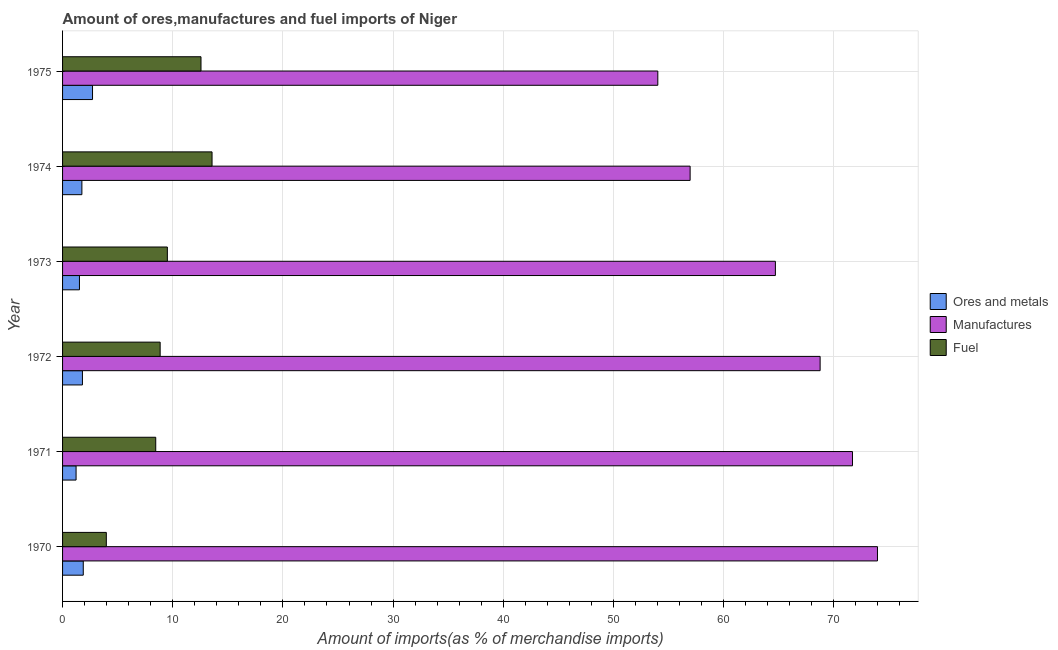How many different coloured bars are there?
Provide a short and direct response. 3. Are the number of bars per tick equal to the number of legend labels?
Give a very brief answer. Yes. Are the number of bars on each tick of the Y-axis equal?
Provide a short and direct response. Yes. What is the percentage of manufactures imports in 1973?
Offer a terse response. 64.71. Across all years, what is the maximum percentage of fuel imports?
Provide a succinct answer. 13.57. Across all years, what is the minimum percentage of manufactures imports?
Make the answer very short. 54.03. In which year was the percentage of ores and metals imports maximum?
Offer a terse response. 1975. What is the total percentage of manufactures imports in the graph?
Keep it short and to the point. 390.14. What is the difference between the percentage of manufactures imports in 1971 and that in 1972?
Offer a very short reply. 2.94. What is the difference between the percentage of ores and metals imports in 1973 and the percentage of manufactures imports in 1975?
Make the answer very short. -52.5. What is the average percentage of ores and metals imports per year?
Provide a succinct answer. 1.82. In the year 1971, what is the difference between the percentage of fuel imports and percentage of manufactures imports?
Your response must be concise. -63.25. What is the ratio of the percentage of fuel imports in 1971 to that in 1972?
Provide a short and direct response. 0.95. What is the difference between the highest and the second highest percentage of fuel imports?
Your answer should be very brief. 1. What is the difference between the highest and the lowest percentage of ores and metals imports?
Your answer should be compact. 1.49. Is the sum of the percentage of ores and metals imports in 1970 and 1975 greater than the maximum percentage of fuel imports across all years?
Your answer should be compact. No. What does the 1st bar from the top in 1970 represents?
Offer a terse response. Fuel. What does the 2nd bar from the bottom in 1971 represents?
Keep it short and to the point. Manufactures. Is it the case that in every year, the sum of the percentage of ores and metals imports and percentage of manufactures imports is greater than the percentage of fuel imports?
Provide a short and direct response. Yes. Are the values on the major ticks of X-axis written in scientific E-notation?
Provide a succinct answer. No. Does the graph contain any zero values?
Offer a terse response. No. Where does the legend appear in the graph?
Keep it short and to the point. Center right. How are the legend labels stacked?
Your answer should be very brief. Vertical. What is the title of the graph?
Offer a very short reply. Amount of ores,manufactures and fuel imports of Niger. Does "ICT services" appear as one of the legend labels in the graph?
Ensure brevity in your answer.  No. What is the label or title of the X-axis?
Give a very brief answer. Amount of imports(as % of merchandise imports). What is the label or title of the Y-axis?
Provide a short and direct response. Year. What is the Amount of imports(as % of merchandise imports) in Ores and metals in 1970?
Provide a short and direct response. 1.88. What is the Amount of imports(as % of merchandise imports) in Manufactures in 1970?
Provide a short and direct response. 73.97. What is the Amount of imports(as % of merchandise imports) of Fuel in 1970?
Ensure brevity in your answer.  3.97. What is the Amount of imports(as % of merchandise imports) of Ores and metals in 1971?
Ensure brevity in your answer.  1.23. What is the Amount of imports(as % of merchandise imports) in Manufactures in 1971?
Your answer should be very brief. 71.7. What is the Amount of imports(as % of merchandise imports) in Fuel in 1971?
Your answer should be very brief. 8.46. What is the Amount of imports(as % of merchandise imports) of Ores and metals in 1972?
Keep it short and to the point. 1.8. What is the Amount of imports(as % of merchandise imports) of Manufactures in 1972?
Make the answer very short. 68.77. What is the Amount of imports(as % of merchandise imports) in Fuel in 1972?
Your answer should be very brief. 8.86. What is the Amount of imports(as % of merchandise imports) of Ores and metals in 1973?
Your answer should be very brief. 1.53. What is the Amount of imports(as % of merchandise imports) of Manufactures in 1973?
Offer a terse response. 64.71. What is the Amount of imports(as % of merchandise imports) of Fuel in 1973?
Offer a terse response. 9.51. What is the Amount of imports(as % of merchandise imports) of Ores and metals in 1974?
Offer a very short reply. 1.75. What is the Amount of imports(as % of merchandise imports) in Manufactures in 1974?
Keep it short and to the point. 56.97. What is the Amount of imports(as % of merchandise imports) of Fuel in 1974?
Provide a short and direct response. 13.57. What is the Amount of imports(as % of merchandise imports) of Ores and metals in 1975?
Your response must be concise. 2.72. What is the Amount of imports(as % of merchandise imports) of Manufactures in 1975?
Your response must be concise. 54.03. What is the Amount of imports(as % of merchandise imports) of Fuel in 1975?
Keep it short and to the point. 12.57. Across all years, what is the maximum Amount of imports(as % of merchandise imports) in Ores and metals?
Your response must be concise. 2.72. Across all years, what is the maximum Amount of imports(as % of merchandise imports) of Manufactures?
Your response must be concise. 73.97. Across all years, what is the maximum Amount of imports(as % of merchandise imports) in Fuel?
Provide a succinct answer. 13.57. Across all years, what is the minimum Amount of imports(as % of merchandise imports) of Ores and metals?
Your answer should be very brief. 1.23. Across all years, what is the minimum Amount of imports(as % of merchandise imports) in Manufactures?
Offer a terse response. 54.03. Across all years, what is the minimum Amount of imports(as % of merchandise imports) of Fuel?
Ensure brevity in your answer.  3.97. What is the total Amount of imports(as % of merchandise imports) in Ores and metals in the graph?
Provide a succinct answer. 10.92. What is the total Amount of imports(as % of merchandise imports) in Manufactures in the graph?
Offer a very short reply. 390.14. What is the total Amount of imports(as % of merchandise imports) of Fuel in the graph?
Keep it short and to the point. 56.93. What is the difference between the Amount of imports(as % of merchandise imports) of Ores and metals in 1970 and that in 1971?
Give a very brief answer. 0.65. What is the difference between the Amount of imports(as % of merchandise imports) of Manufactures in 1970 and that in 1971?
Offer a terse response. 2.27. What is the difference between the Amount of imports(as % of merchandise imports) of Fuel in 1970 and that in 1971?
Your answer should be very brief. -4.48. What is the difference between the Amount of imports(as % of merchandise imports) of Ores and metals in 1970 and that in 1972?
Make the answer very short. 0.08. What is the difference between the Amount of imports(as % of merchandise imports) of Manufactures in 1970 and that in 1972?
Your response must be concise. 5.2. What is the difference between the Amount of imports(as % of merchandise imports) of Fuel in 1970 and that in 1972?
Provide a succinct answer. -4.89. What is the difference between the Amount of imports(as % of merchandise imports) of Ores and metals in 1970 and that in 1973?
Your answer should be very brief. 0.35. What is the difference between the Amount of imports(as % of merchandise imports) in Manufactures in 1970 and that in 1973?
Keep it short and to the point. 9.27. What is the difference between the Amount of imports(as % of merchandise imports) of Fuel in 1970 and that in 1973?
Offer a terse response. -5.54. What is the difference between the Amount of imports(as % of merchandise imports) of Ores and metals in 1970 and that in 1974?
Your response must be concise. 0.13. What is the difference between the Amount of imports(as % of merchandise imports) of Manufactures in 1970 and that in 1974?
Offer a very short reply. 17.01. What is the difference between the Amount of imports(as % of merchandise imports) in Fuel in 1970 and that in 1974?
Ensure brevity in your answer.  -9.6. What is the difference between the Amount of imports(as % of merchandise imports) of Ores and metals in 1970 and that in 1975?
Your answer should be very brief. -0.84. What is the difference between the Amount of imports(as % of merchandise imports) in Manufactures in 1970 and that in 1975?
Provide a succinct answer. 19.94. What is the difference between the Amount of imports(as % of merchandise imports) in Fuel in 1970 and that in 1975?
Your answer should be very brief. -8.59. What is the difference between the Amount of imports(as % of merchandise imports) of Ores and metals in 1971 and that in 1972?
Provide a short and direct response. -0.58. What is the difference between the Amount of imports(as % of merchandise imports) of Manufactures in 1971 and that in 1972?
Ensure brevity in your answer.  2.94. What is the difference between the Amount of imports(as % of merchandise imports) of Fuel in 1971 and that in 1972?
Ensure brevity in your answer.  -0.4. What is the difference between the Amount of imports(as % of merchandise imports) in Ores and metals in 1971 and that in 1973?
Your answer should be compact. -0.31. What is the difference between the Amount of imports(as % of merchandise imports) of Manufactures in 1971 and that in 1973?
Your answer should be very brief. 7. What is the difference between the Amount of imports(as % of merchandise imports) of Fuel in 1971 and that in 1973?
Your answer should be compact. -1.06. What is the difference between the Amount of imports(as % of merchandise imports) of Ores and metals in 1971 and that in 1974?
Keep it short and to the point. -0.53. What is the difference between the Amount of imports(as % of merchandise imports) in Manufactures in 1971 and that in 1974?
Your answer should be very brief. 14.74. What is the difference between the Amount of imports(as % of merchandise imports) of Fuel in 1971 and that in 1974?
Make the answer very short. -5.11. What is the difference between the Amount of imports(as % of merchandise imports) of Ores and metals in 1971 and that in 1975?
Your answer should be very brief. -1.49. What is the difference between the Amount of imports(as % of merchandise imports) of Manufactures in 1971 and that in 1975?
Your answer should be very brief. 17.67. What is the difference between the Amount of imports(as % of merchandise imports) in Fuel in 1971 and that in 1975?
Provide a short and direct response. -4.11. What is the difference between the Amount of imports(as % of merchandise imports) of Ores and metals in 1972 and that in 1973?
Provide a succinct answer. 0.27. What is the difference between the Amount of imports(as % of merchandise imports) of Manufactures in 1972 and that in 1973?
Give a very brief answer. 4.06. What is the difference between the Amount of imports(as % of merchandise imports) in Fuel in 1972 and that in 1973?
Keep it short and to the point. -0.65. What is the difference between the Amount of imports(as % of merchandise imports) in Ores and metals in 1972 and that in 1974?
Keep it short and to the point. 0.05. What is the difference between the Amount of imports(as % of merchandise imports) of Manufactures in 1972 and that in 1974?
Give a very brief answer. 11.8. What is the difference between the Amount of imports(as % of merchandise imports) of Fuel in 1972 and that in 1974?
Offer a terse response. -4.71. What is the difference between the Amount of imports(as % of merchandise imports) of Ores and metals in 1972 and that in 1975?
Your answer should be compact. -0.92. What is the difference between the Amount of imports(as % of merchandise imports) of Manufactures in 1972 and that in 1975?
Offer a very short reply. 14.73. What is the difference between the Amount of imports(as % of merchandise imports) of Fuel in 1972 and that in 1975?
Your answer should be very brief. -3.71. What is the difference between the Amount of imports(as % of merchandise imports) in Ores and metals in 1973 and that in 1974?
Offer a very short reply. -0.22. What is the difference between the Amount of imports(as % of merchandise imports) of Manufactures in 1973 and that in 1974?
Give a very brief answer. 7.74. What is the difference between the Amount of imports(as % of merchandise imports) in Fuel in 1973 and that in 1974?
Offer a very short reply. -4.06. What is the difference between the Amount of imports(as % of merchandise imports) of Ores and metals in 1973 and that in 1975?
Give a very brief answer. -1.19. What is the difference between the Amount of imports(as % of merchandise imports) in Manufactures in 1973 and that in 1975?
Keep it short and to the point. 10.67. What is the difference between the Amount of imports(as % of merchandise imports) in Fuel in 1973 and that in 1975?
Offer a very short reply. -3.05. What is the difference between the Amount of imports(as % of merchandise imports) of Ores and metals in 1974 and that in 1975?
Make the answer very short. -0.97. What is the difference between the Amount of imports(as % of merchandise imports) in Manufactures in 1974 and that in 1975?
Offer a very short reply. 2.93. What is the difference between the Amount of imports(as % of merchandise imports) of Ores and metals in 1970 and the Amount of imports(as % of merchandise imports) of Manufactures in 1971?
Make the answer very short. -69.82. What is the difference between the Amount of imports(as % of merchandise imports) of Ores and metals in 1970 and the Amount of imports(as % of merchandise imports) of Fuel in 1971?
Ensure brevity in your answer.  -6.58. What is the difference between the Amount of imports(as % of merchandise imports) of Manufactures in 1970 and the Amount of imports(as % of merchandise imports) of Fuel in 1971?
Offer a very short reply. 65.51. What is the difference between the Amount of imports(as % of merchandise imports) in Ores and metals in 1970 and the Amount of imports(as % of merchandise imports) in Manufactures in 1972?
Keep it short and to the point. -66.89. What is the difference between the Amount of imports(as % of merchandise imports) in Ores and metals in 1970 and the Amount of imports(as % of merchandise imports) in Fuel in 1972?
Your response must be concise. -6.98. What is the difference between the Amount of imports(as % of merchandise imports) of Manufactures in 1970 and the Amount of imports(as % of merchandise imports) of Fuel in 1972?
Your answer should be very brief. 65.11. What is the difference between the Amount of imports(as % of merchandise imports) in Ores and metals in 1970 and the Amount of imports(as % of merchandise imports) in Manufactures in 1973?
Offer a very short reply. -62.83. What is the difference between the Amount of imports(as % of merchandise imports) of Ores and metals in 1970 and the Amount of imports(as % of merchandise imports) of Fuel in 1973?
Make the answer very short. -7.63. What is the difference between the Amount of imports(as % of merchandise imports) in Manufactures in 1970 and the Amount of imports(as % of merchandise imports) in Fuel in 1973?
Offer a very short reply. 64.46. What is the difference between the Amount of imports(as % of merchandise imports) in Ores and metals in 1970 and the Amount of imports(as % of merchandise imports) in Manufactures in 1974?
Your answer should be very brief. -55.09. What is the difference between the Amount of imports(as % of merchandise imports) in Ores and metals in 1970 and the Amount of imports(as % of merchandise imports) in Fuel in 1974?
Provide a short and direct response. -11.69. What is the difference between the Amount of imports(as % of merchandise imports) in Manufactures in 1970 and the Amount of imports(as % of merchandise imports) in Fuel in 1974?
Make the answer very short. 60.4. What is the difference between the Amount of imports(as % of merchandise imports) in Ores and metals in 1970 and the Amount of imports(as % of merchandise imports) in Manufactures in 1975?
Your answer should be very brief. -52.15. What is the difference between the Amount of imports(as % of merchandise imports) of Ores and metals in 1970 and the Amount of imports(as % of merchandise imports) of Fuel in 1975?
Your answer should be compact. -10.69. What is the difference between the Amount of imports(as % of merchandise imports) of Manufactures in 1970 and the Amount of imports(as % of merchandise imports) of Fuel in 1975?
Your answer should be very brief. 61.41. What is the difference between the Amount of imports(as % of merchandise imports) in Ores and metals in 1971 and the Amount of imports(as % of merchandise imports) in Manufactures in 1972?
Provide a short and direct response. -67.54. What is the difference between the Amount of imports(as % of merchandise imports) in Ores and metals in 1971 and the Amount of imports(as % of merchandise imports) in Fuel in 1972?
Provide a short and direct response. -7.63. What is the difference between the Amount of imports(as % of merchandise imports) of Manufactures in 1971 and the Amount of imports(as % of merchandise imports) of Fuel in 1972?
Give a very brief answer. 62.84. What is the difference between the Amount of imports(as % of merchandise imports) of Ores and metals in 1971 and the Amount of imports(as % of merchandise imports) of Manufactures in 1973?
Your response must be concise. -63.48. What is the difference between the Amount of imports(as % of merchandise imports) of Ores and metals in 1971 and the Amount of imports(as % of merchandise imports) of Fuel in 1973?
Offer a very short reply. -8.29. What is the difference between the Amount of imports(as % of merchandise imports) of Manufactures in 1971 and the Amount of imports(as % of merchandise imports) of Fuel in 1973?
Provide a short and direct response. 62.19. What is the difference between the Amount of imports(as % of merchandise imports) in Ores and metals in 1971 and the Amount of imports(as % of merchandise imports) in Manufactures in 1974?
Your answer should be very brief. -55.74. What is the difference between the Amount of imports(as % of merchandise imports) in Ores and metals in 1971 and the Amount of imports(as % of merchandise imports) in Fuel in 1974?
Your response must be concise. -12.34. What is the difference between the Amount of imports(as % of merchandise imports) in Manufactures in 1971 and the Amount of imports(as % of merchandise imports) in Fuel in 1974?
Make the answer very short. 58.13. What is the difference between the Amount of imports(as % of merchandise imports) in Ores and metals in 1971 and the Amount of imports(as % of merchandise imports) in Manufactures in 1975?
Ensure brevity in your answer.  -52.81. What is the difference between the Amount of imports(as % of merchandise imports) of Ores and metals in 1971 and the Amount of imports(as % of merchandise imports) of Fuel in 1975?
Your answer should be compact. -11.34. What is the difference between the Amount of imports(as % of merchandise imports) of Manufactures in 1971 and the Amount of imports(as % of merchandise imports) of Fuel in 1975?
Provide a succinct answer. 59.14. What is the difference between the Amount of imports(as % of merchandise imports) of Ores and metals in 1972 and the Amount of imports(as % of merchandise imports) of Manufactures in 1973?
Give a very brief answer. -62.9. What is the difference between the Amount of imports(as % of merchandise imports) in Ores and metals in 1972 and the Amount of imports(as % of merchandise imports) in Fuel in 1973?
Your answer should be compact. -7.71. What is the difference between the Amount of imports(as % of merchandise imports) of Manufactures in 1972 and the Amount of imports(as % of merchandise imports) of Fuel in 1973?
Ensure brevity in your answer.  59.25. What is the difference between the Amount of imports(as % of merchandise imports) of Ores and metals in 1972 and the Amount of imports(as % of merchandise imports) of Manufactures in 1974?
Offer a very short reply. -55.16. What is the difference between the Amount of imports(as % of merchandise imports) in Ores and metals in 1972 and the Amount of imports(as % of merchandise imports) in Fuel in 1974?
Offer a terse response. -11.77. What is the difference between the Amount of imports(as % of merchandise imports) of Manufactures in 1972 and the Amount of imports(as % of merchandise imports) of Fuel in 1974?
Your answer should be very brief. 55.2. What is the difference between the Amount of imports(as % of merchandise imports) in Ores and metals in 1972 and the Amount of imports(as % of merchandise imports) in Manufactures in 1975?
Keep it short and to the point. -52.23. What is the difference between the Amount of imports(as % of merchandise imports) in Ores and metals in 1972 and the Amount of imports(as % of merchandise imports) in Fuel in 1975?
Keep it short and to the point. -10.76. What is the difference between the Amount of imports(as % of merchandise imports) of Manufactures in 1972 and the Amount of imports(as % of merchandise imports) of Fuel in 1975?
Your answer should be very brief. 56.2. What is the difference between the Amount of imports(as % of merchandise imports) in Ores and metals in 1973 and the Amount of imports(as % of merchandise imports) in Manufactures in 1974?
Ensure brevity in your answer.  -55.43. What is the difference between the Amount of imports(as % of merchandise imports) in Ores and metals in 1973 and the Amount of imports(as % of merchandise imports) in Fuel in 1974?
Your response must be concise. -12.04. What is the difference between the Amount of imports(as % of merchandise imports) of Manufactures in 1973 and the Amount of imports(as % of merchandise imports) of Fuel in 1974?
Provide a succinct answer. 51.14. What is the difference between the Amount of imports(as % of merchandise imports) in Ores and metals in 1973 and the Amount of imports(as % of merchandise imports) in Manufactures in 1975?
Offer a very short reply. -52.5. What is the difference between the Amount of imports(as % of merchandise imports) in Ores and metals in 1973 and the Amount of imports(as % of merchandise imports) in Fuel in 1975?
Make the answer very short. -11.03. What is the difference between the Amount of imports(as % of merchandise imports) of Manufactures in 1973 and the Amount of imports(as % of merchandise imports) of Fuel in 1975?
Ensure brevity in your answer.  52.14. What is the difference between the Amount of imports(as % of merchandise imports) in Ores and metals in 1974 and the Amount of imports(as % of merchandise imports) in Manufactures in 1975?
Provide a short and direct response. -52.28. What is the difference between the Amount of imports(as % of merchandise imports) of Ores and metals in 1974 and the Amount of imports(as % of merchandise imports) of Fuel in 1975?
Offer a very short reply. -10.81. What is the difference between the Amount of imports(as % of merchandise imports) in Manufactures in 1974 and the Amount of imports(as % of merchandise imports) in Fuel in 1975?
Give a very brief answer. 44.4. What is the average Amount of imports(as % of merchandise imports) of Ores and metals per year?
Your response must be concise. 1.82. What is the average Amount of imports(as % of merchandise imports) of Manufactures per year?
Your response must be concise. 65.02. What is the average Amount of imports(as % of merchandise imports) of Fuel per year?
Provide a succinct answer. 9.49. In the year 1970, what is the difference between the Amount of imports(as % of merchandise imports) in Ores and metals and Amount of imports(as % of merchandise imports) in Manufactures?
Offer a very short reply. -72.09. In the year 1970, what is the difference between the Amount of imports(as % of merchandise imports) of Ores and metals and Amount of imports(as % of merchandise imports) of Fuel?
Your answer should be very brief. -2.09. In the year 1970, what is the difference between the Amount of imports(as % of merchandise imports) of Manufactures and Amount of imports(as % of merchandise imports) of Fuel?
Offer a terse response. 70. In the year 1971, what is the difference between the Amount of imports(as % of merchandise imports) of Ores and metals and Amount of imports(as % of merchandise imports) of Manufactures?
Make the answer very short. -70.48. In the year 1971, what is the difference between the Amount of imports(as % of merchandise imports) of Ores and metals and Amount of imports(as % of merchandise imports) of Fuel?
Provide a short and direct response. -7.23. In the year 1971, what is the difference between the Amount of imports(as % of merchandise imports) of Manufactures and Amount of imports(as % of merchandise imports) of Fuel?
Keep it short and to the point. 63.25. In the year 1972, what is the difference between the Amount of imports(as % of merchandise imports) of Ores and metals and Amount of imports(as % of merchandise imports) of Manufactures?
Your answer should be very brief. -66.96. In the year 1972, what is the difference between the Amount of imports(as % of merchandise imports) in Ores and metals and Amount of imports(as % of merchandise imports) in Fuel?
Offer a terse response. -7.05. In the year 1972, what is the difference between the Amount of imports(as % of merchandise imports) in Manufactures and Amount of imports(as % of merchandise imports) in Fuel?
Your answer should be compact. 59.91. In the year 1973, what is the difference between the Amount of imports(as % of merchandise imports) of Ores and metals and Amount of imports(as % of merchandise imports) of Manufactures?
Your answer should be compact. -63.17. In the year 1973, what is the difference between the Amount of imports(as % of merchandise imports) of Ores and metals and Amount of imports(as % of merchandise imports) of Fuel?
Give a very brief answer. -7.98. In the year 1973, what is the difference between the Amount of imports(as % of merchandise imports) of Manufactures and Amount of imports(as % of merchandise imports) of Fuel?
Give a very brief answer. 55.19. In the year 1974, what is the difference between the Amount of imports(as % of merchandise imports) in Ores and metals and Amount of imports(as % of merchandise imports) in Manufactures?
Your answer should be very brief. -55.21. In the year 1974, what is the difference between the Amount of imports(as % of merchandise imports) of Ores and metals and Amount of imports(as % of merchandise imports) of Fuel?
Keep it short and to the point. -11.81. In the year 1974, what is the difference between the Amount of imports(as % of merchandise imports) in Manufactures and Amount of imports(as % of merchandise imports) in Fuel?
Your response must be concise. 43.4. In the year 1975, what is the difference between the Amount of imports(as % of merchandise imports) in Ores and metals and Amount of imports(as % of merchandise imports) in Manufactures?
Your answer should be compact. -51.31. In the year 1975, what is the difference between the Amount of imports(as % of merchandise imports) in Ores and metals and Amount of imports(as % of merchandise imports) in Fuel?
Your answer should be compact. -9.85. In the year 1975, what is the difference between the Amount of imports(as % of merchandise imports) of Manufactures and Amount of imports(as % of merchandise imports) of Fuel?
Ensure brevity in your answer.  41.47. What is the ratio of the Amount of imports(as % of merchandise imports) in Ores and metals in 1970 to that in 1971?
Give a very brief answer. 1.53. What is the ratio of the Amount of imports(as % of merchandise imports) of Manufactures in 1970 to that in 1971?
Offer a very short reply. 1.03. What is the ratio of the Amount of imports(as % of merchandise imports) in Fuel in 1970 to that in 1971?
Provide a short and direct response. 0.47. What is the ratio of the Amount of imports(as % of merchandise imports) of Ores and metals in 1970 to that in 1972?
Give a very brief answer. 1.04. What is the ratio of the Amount of imports(as % of merchandise imports) in Manufactures in 1970 to that in 1972?
Ensure brevity in your answer.  1.08. What is the ratio of the Amount of imports(as % of merchandise imports) of Fuel in 1970 to that in 1972?
Ensure brevity in your answer.  0.45. What is the ratio of the Amount of imports(as % of merchandise imports) in Ores and metals in 1970 to that in 1973?
Keep it short and to the point. 1.23. What is the ratio of the Amount of imports(as % of merchandise imports) in Manufactures in 1970 to that in 1973?
Ensure brevity in your answer.  1.14. What is the ratio of the Amount of imports(as % of merchandise imports) in Fuel in 1970 to that in 1973?
Give a very brief answer. 0.42. What is the ratio of the Amount of imports(as % of merchandise imports) in Ores and metals in 1970 to that in 1974?
Your response must be concise. 1.07. What is the ratio of the Amount of imports(as % of merchandise imports) of Manufactures in 1970 to that in 1974?
Provide a short and direct response. 1.3. What is the ratio of the Amount of imports(as % of merchandise imports) of Fuel in 1970 to that in 1974?
Your answer should be very brief. 0.29. What is the ratio of the Amount of imports(as % of merchandise imports) of Ores and metals in 1970 to that in 1975?
Provide a short and direct response. 0.69. What is the ratio of the Amount of imports(as % of merchandise imports) of Manufactures in 1970 to that in 1975?
Keep it short and to the point. 1.37. What is the ratio of the Amount of imports(as % of merchandise imports) in Fuel in 1970 to that in 1975?
Offer a terse response. 0.32. What is the ratio of the Amount of imports(as % of merchandise imports) in Ores and metals in 1971 to that in 1972?
Ensure brevity in your answer.  0.68. What is the ratio of the Amount of imports(as % of merchandise imports) in Manufactures in 1971 to that in 1972?
Offer a very short reply. 1.04. What is the ratio of the Amount of imports(as % of merchandise imports) of Fuel in 1971 to that in 1972?
Offer a terse response. 0.95. What is the ratio of the Amount of imports(as % of merchandise imports) in Ores and metals in 1971 to that in 1973?
Provide a succinct answer. 0.8. What is the ratio of the Amount of imports(as % of merchandise imports) of Manufactures in 1971 to that in 1973?
Ensure brevity in your answer.  1.11. What is the ratio of the Amount of imports(as % of merchandise imports) in Fuel in 1971 to that in 1973?
Keep it short and to the point. 0.89. What is the ratio of the Amount of imports(as % of merchandise imports) of Ores and metals in 1971 to that in 1974?
Your answer should be very brief. 0.7. What is the ratio of the Amount of imports(as % of merchandise imports) of Manufactures in 1971 to that in 1974?
Offer a terse response. 1.26. What is the ratio of the Amount of imports(as % of merchandise imports) in Fuel in 1971 to that in 1974?
Provide a short and direct response. 0.62. What is the ratio of the Amount of imports(as % of merchandise imports) in Ores and metals in 1971 to that in 1975?
Provide a succinct answer. 0.45. What is the ratio of the Amount of imports(as % of merchandise imports) in Manufactures in 1971 to that in 1975?
Make the answer very short. 1.33. What is the ratio of the Amount of imports(as % of merchandise imports) of Fuel in 1971 to that in 1975?
Provide a succinct answer. 0.67. What is the ratio of the Amount of imports(as % of merchandise imports) of Ores and metals in 1972 to that in 1973?
Ensure brevity in your answer.  1.18. What is the ratio of the Amount of imports(as % of merchandise imports) in Manufactures in 1972 to that in 1973?
Your answer should be compact. 1.06. What is the ratio of the Amount of imports(as % of merchandise imports) in Fuel in 1972 to that in 1973?
Provide a short and direct response. 0.93. What is the ratio of the Amount of imports(as % of merchandise imports) of Ores and metals in 1972 to that in 1974?
Keep it short and to the point. 1.03. What is the ratio of the Amount of imports(as % of merchandise imports) in Manufactures in 1972 to that in 1974?
Provide a short and direct response. 1.21. What is the ratio of the Amount of imports(as % of merchandise imports) in Fuel in 1972 to that in 1974?
Your answer should be very brief. 0.65. What is the ratio of the Amount of imports(as % of merchandise imports) in Ores and metals in 1972 to that in 1975?
Give a very brief answer. 0.66. What is the ratio of the Amount of imports(as % of merchandise imports) in Manufactures in 1972 to that in 1975?
Give a very brief answer. 1.27. What is the ratio of the Amount of imports(as % of merchandise imports) in Fuel in 1972 to that in 1975?
Offer a terse response. 0.7. What is the ratio of the Amount of imports(as % of merchandise imports) in Ores and metals in 1973 to that in 1974?
Give a very brief answer. 0.87. What is the ratio of the Amount of imports(as % of merchandise imports) in Manufactures in 1973 to that in 1974?
Offer a very short reply. 1.14. What is the ratio of the Amount of imports(as % of merchandise imports) of Fuel in 1973 to that in 1974?
Provide a short and direct response. 0.7. What is the ratio of the Amount of imports(as % of merchandise imports) in Ores and metals in 1973 to that in 1975?
Your answer should be very brief. 0.56. What is the ratio of the Amount of imports(as % of merchandise imports) of Manufactures in 1973 to that in 1975?
Ensure brevity in your answer.  1.2. What is the ratio of the Amount of imports(as % of merchandise imports) in Fuel in 1973 to that in 1975?
Provide a short and direct response. 0.76. What is the ratio of the Amount of imports(as % of merchandise imports) of Ores and metals in 1974 to that in 1975?
Ensure brevity in your answer.  0.64. What is the ratio of the Amount of imports(as % of merchandise imports) of Manufactures in 1974 to that in 1975?
Provide a succinct answer. 1.05. What is the ratio of the Amount of imports(as % of merchandise imports) of Fuel in 1974 to that in 1975?
Provide a succinct answer. 1.08. What is the difference between the highest and the second highest Amount of imports(as % of merchandise imports) of Ores and metals?
Provide a short and direct response. 0.84. What is the difference between the highest and the second highest Amount of imports(as % of merchandise imports) in Manufactures?
Your answer should be compact. 2.27. What is the difference between the highest and the second highest Amount of imports(as % of merchandise imports) in Fuel?
Your answer should be compact. 1. What is the difference between the highest and the lowest Amount of imports(as % of merchandise imports) in Ores and metals?
Keep it short and to the point. 1.49. What is the difference between the highest and the lowest Amount of imports(as % of merchandise imports) of Manufactures?
Give a very brief answer. 19.94. What is the difference between the highest and the lowest Amount of imports(as % of merchandise imports) in Fuel?
Provide a succinct answer. 9.6. 